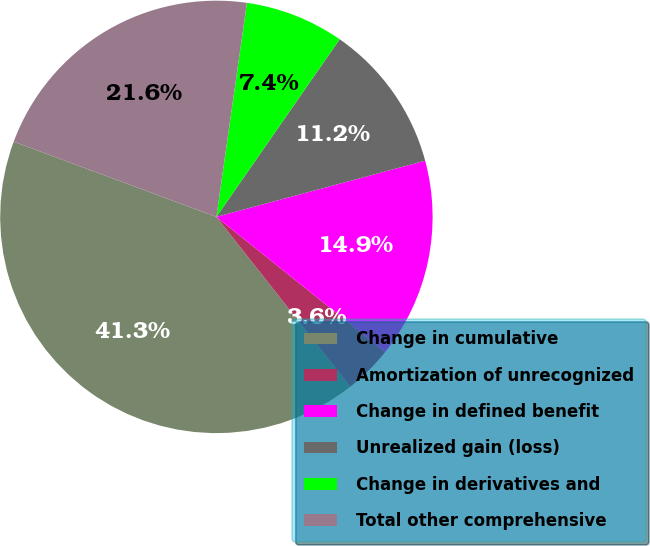<chart> <loc_0><loc_0><loc_500><loc_500><pie_chart><fcel>Change in cumulative<fcel>Amortization of unrecognized<fcel>Change in defined benefit<fcel>Unrealized gain (loss)<fcel>Change in derivatives and<fcel>Total other comprehensive<nl><fcel>41.28%<fcel>3.63%<fcel>14.93%<fcel>11.16%<fcel>7.4%<fcel>21.6%<nl></chart> 